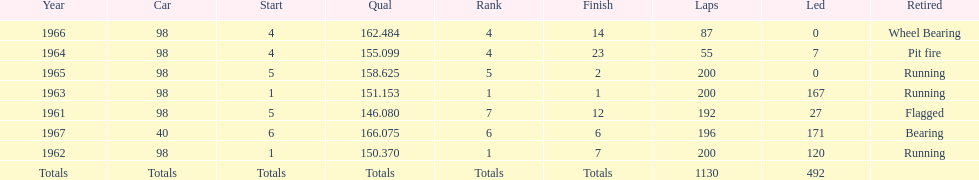What was his best finish before his first win? 7. 